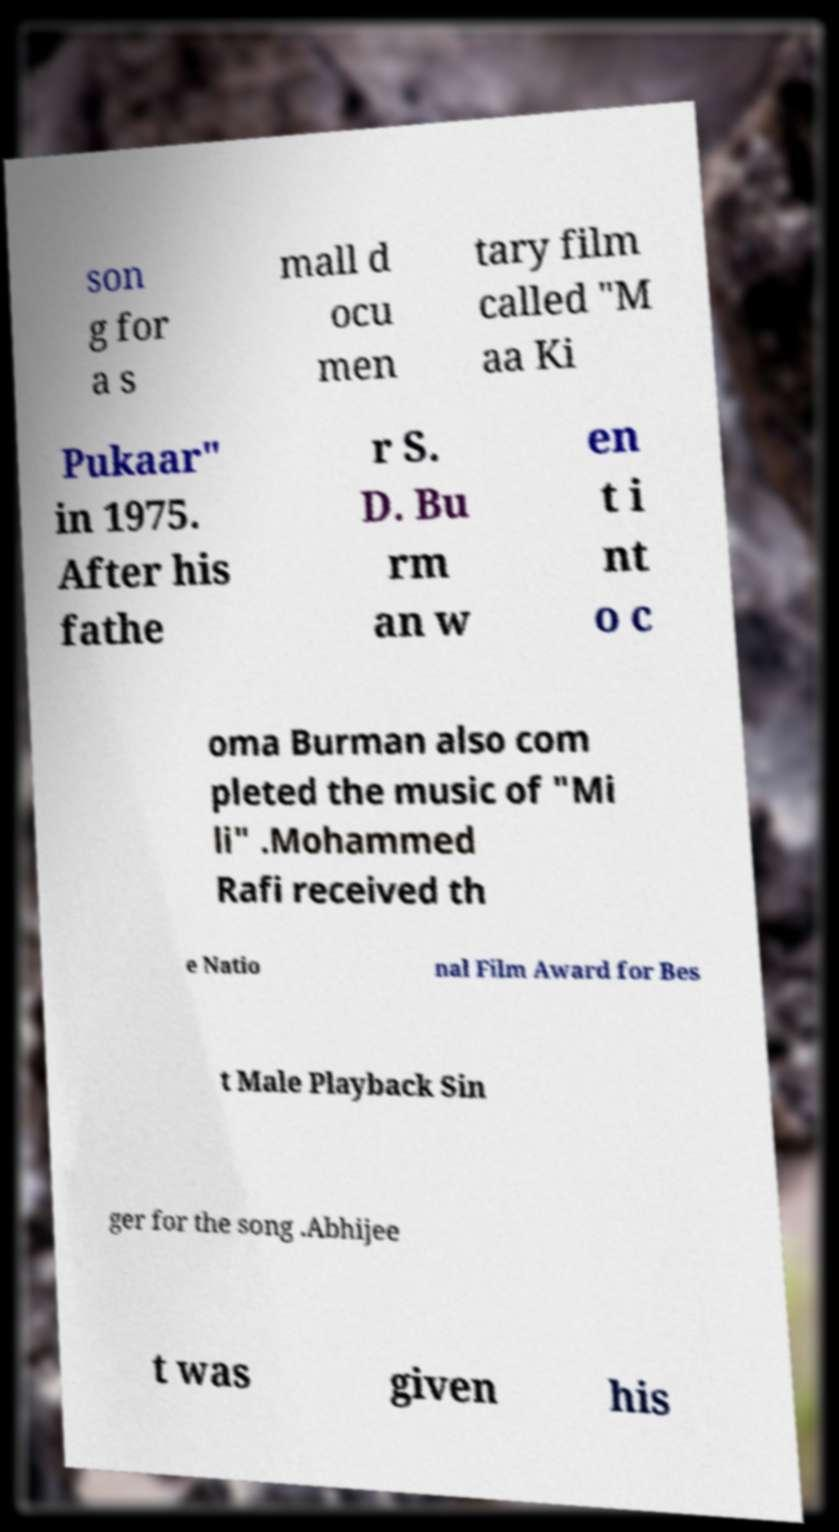For documentation purposes, I need the text within this image transcribed. Could you provide that? son g for a s mall d ocu men tary film called "M aa Ki Pukaar" in 1975. After his fathe r S. D. Bu rm an w en t i nt o c oma Burman also com pleted the music of "Mi li" .Mohammed Rafi received th e Natio nal Film Award for Bes t Male Playback Sin ger for the song .Abhijee t was given his 